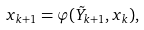<formula> <loc_0><loc_0><loc_500><loc_500>x _ { k + 1 } = \varphi ( \tilde { Y } _ { k + 1 } , x _ { k } ) ,</formula> 